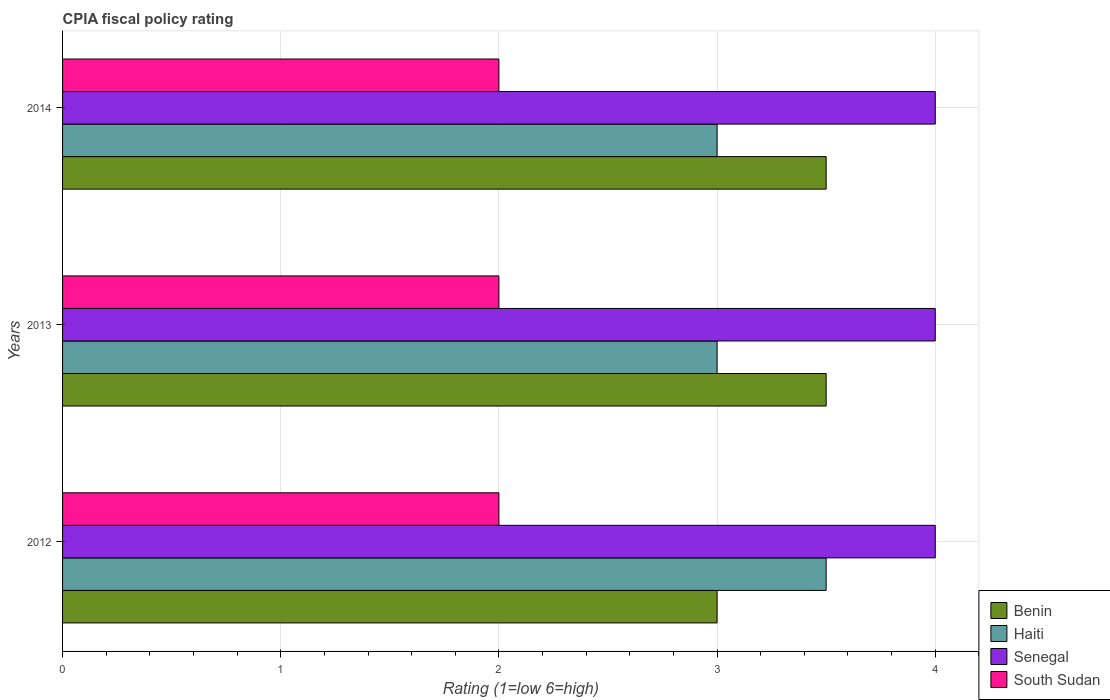How many different coloured bars are there?
Ensure brevity in your answer.  4. How many bars are there on the 3rd tick from the top?
Make the answer very short. 4. How many bars are there on the 3rd tick from the bottom?
Your answer should be compact. 4. Across all years, what is the maximum CPIA rating in South Sudan?
Your answer should be very brief. 2. Across all years, what is the minimum CPIA rating in Senegal?
Provide a short and direct response. 4. In which year was the CPIA rating in Benin maximum?
Your response must be concise. 2013. What is the total CPIA rating in South Sudan in the graph?
Ensure brevity in your answer.  6. What is the difference between the CPIA rating in Senegal in 2012 and that in 2014?
Give a very brief answer. 0. What is the difference between the CPIA rating in Haiti in 2014 and the CPIA rating in Benin in 2013?
Your response must be concise. -0.5. What is the average CPIA rating in South Sudan per year?
Offer a very short reply. 2. In the year 2013, what is the difference between the CPIA rating in Senegal and CPIA rating in Haiti?
Give a very brief answer. 1. Is the difference between the CPIA rating in Senegal in 2013 and 2014 greater than the difference between the CPIA rating in Haiti in 2013 and 2014?
Provide a succinct answer. No. What does the 1st bar from the top in 2012 represents?
Ensure brevity in your answer.  South Sudan. What does the 1st bar from the bottom in 2014 represents?
Keep it short and to the point. Benin. How many bars are there?
Keep it short and to the point. 12. Are all the bars in the graph horizontal?
Provide a short and direct response. Yes. Are the values on the major ticks of X-axis written in scientific E-notation?
Your answer should be compact. No. Does the graph contain grids?
Provide a short and direct response. Yes. How many legend labels are there?
Ensure brevity in your answer.  4. How are the legend labels stacked?
Keep it short and to the point. Vertical. What is the title of the graph?
Your response must be concise. CPIA fiscal policy rating. Does "Kuwait" appear as one of the legend labels in the graph?
Make the answer very short. No. What is the label or title of the X-axis?
Keep it short and to the point. Rating (1=low 6=high). What is the label or title of the Y-axis?
Your answer should be very brief. Years. What is the Rating (1=low 6=high) in Benin in 2013?
Your answer should be compact. 3.5. What is the Rating (1=low 6=high) of Benin in 2014?
Provide a short and direct response. 3.5. What is the Rating (1=low 6=high) in South Sudan in 2014?
Your response must be concise. 2. Across all years, what is the maximum Rating (1=low 6=high) in Benin?
Give a very brief answer. 3.5. Across all years, what is the maximum Rating (1=low 6=high) of Haiti?
Your answer should be compact. 3.5. Across all years, what is the maximum Rating (1=low 6=high) of South Sudan?
Your response must be concise. 2. Across all years, what is the minimum Rating (1=low 6=high) of Benin?
Your response must be concise. 3. Across all years, what is the minimum Rating (1=low 6=high) in Senegal?
Ensure brevity in your answer.  4. What is the total Rating (1=low 6=high) in Benin in the graph?
Ensure brevity in your answer.  10. What is the total Rating (1=low 6=high) in Haiti in the graph?
Your answer should be compact. 9.5. What is the total Rating (1=low 6=high) in Senegal in the graph?
Ensure brevity in your answer.  12. What is the total Rating (1=low 6=high) in South Sudan in the graph?
Provide a short and direct response. 6. What is the difference between the Rating (1=low 6=high) of Benin in 2012 and that in 2013?
Ensure brevity in your answer.  -0.5. What is the difference between the Rating (1=low 6=high) in Senegal in 2012 and that in 2013?
Make the answer very short. 0. What is the difference between the Rating (1=low 6=high) in Benin in 2012 and that in 2014?
Your response must be concise. -0.5. What is the difference between the Rating (1=low 6=high) of Haiti in 2012 and that in 2014?
Your answer should be very brief. 0.5. What is the difference between the Rating (1=low 6=high) of Senegal in 2012 and that in 2014?
Provide a short and direct response. 0. What is the difference between the Rating (1=low 6=high) in South Sudan in 2012 and that in 2014?
Provide a succinct answer. 0. What is the difference between the Rating (1=low 6=high) in Benin in 2013 and that in 2014?
Provide a succinct answer. 0. What is the difference between the Rating (1=low 6=high) in Haiti in 2013 and that in 2014?
Give a very brief answer. 0. What is the difference between the Rating (1=low 6=high) in South Sudan in 2013 and that in 2014?
Keep it short and to the point. 0. What is the difference between the Rating (1=low 6=high) in Benin in 2012 and the Rating (1=low 6=high) in Senegal in 2013?
Your answer should be very brief. -1. What is the difference between the Rating (1=low 6=high) in Benin in 2012 and the Rating (1=low 6=high) in South Sudan in 2013?
Your response must be concise. 1. What is the difference between the Rating (1=low 6=high) of Benin in 2012 and the Rating (1=low 6=high) of Haiti in 2014?
Keep it short and to the point. 0. What is the difference between the Rating (1=low 6=high) of Benin in 2012 and the Rating (1=low 6=high) of Senegal in 2014?
Give a very brief answer. -1. What is the difference between the Rating (1=low 6=high) of Benin in 2013 and the Rating (1=low 6=high) of Haiti in 2014?
Your answer should be compact. 0.5. What is the difference between the Rating (1=low 6=high) in Haiti in 2013 and the Rating (1=low 6=high) in Senegal in 2014?
Your response must be concise. -1. What is the average Rating (1=low 6=high) of Benin per year?
Your answer should be very brief. 3.33. What is the average Rating (1=low 6=high) of Haiti per year?
Keep it short and to the point. 3.17. In the year 2012, what is the difference between the Rating (1=low 6=high) in Benin and Rating (1=low 6=high) in Haiti?
Your response must be concise. -0.5. In the year 2012, what is the difference between the Rating (1=low 6=high) of Benin and Rating (1=low 6=high) of South Sudan?
Provide a short and direct response. 1. In the year 2013, what is the difference between the Rating (1=low 6=high) of Haiti and Rating (1=low 6=high) of Senegal?
Ensure brevity in your answer.  -1. In the year 2013, what is the difference between the Rating (1=low 6=high) of Haiti and Rating (1=low 6=high) of South Sudan?
Your answer should be compact. 1. In the year 2014, what is the difference between the Rating (1=low 6=high) in Benin and Rating (1=low 6=high) in Senegal?
Ensure brevity in your answer.  -0.5. In the year 2014, what is the difference between the Rating (1=low 6=high) of Haiti and Rating (1=low 6=high) of South Sudan?
Keep it short and to the point. 1. In the year 2014, what is the difference between the Rating (1=low 6=high) in Senegal and Rating (1=low 6=high) in South Sudan?
Offer a very short reply. 2. What is the ratio of the Rating (1=low 6=high) in Benin in 2012 to that in 2013?
Your response must be concise. 0.86. What is the ratio of the Rating (1=low 6=high) of Haiti in 2012 to that in 2013?
Offer a very short reply. 1.17. What is the ratio of the Rating (1=low 6=high) of Senegal in 2012 to that in 2013?
Your response must be concise. 1. What is the ratio of the Rating (1=low 6=high) in Benin in 2012 to that in 2014?
Make the answer very short. 0.86. What is the ratio of the Rating (1=low 6=high) of Haiti in 2012 to that in 2014?
Your answer should be compact. 1.17. What is the ratio of the Rating (1=low 6=high) in Senegal in 2012 to that in 2014?
Provide a succinct answer. 1. What is the ratio of the Rating (1=low 6=high) of South Sudan in 2012 to that in 2014?
Offer a very short reply. 1. What is the ratio of the Rating (1=low 6=high) in Haiti in 2013 to that in 2014?
Provide a succinct answer. 1. What is the ratio of the Rating (1=low 6=high) in Senegal in 2013 to that in 2014?
Make the answer very short. 1. What is the ratio of the Rating (1=low 6=high) of South Sudan in 2013 to that in 2014?
Make the answer very short. 1. What is the difference between the highest and the second highest Rating (1=low 6=high) of Benin?
Your answer should be very brief. 0. What is the difference between the highest and the second highest Rating (1=low 6=high) in Haiti?
Keep it short and to the point. 0.5. What is the difference between the highest and the second highest Rating (1=low 6=high) in South Sudan?
Your answer should be compact. 0. What is the difference between the highest and the lowest Rating (1=low 6=high) in Haiti?
Offer a very short reply. 0.5. 